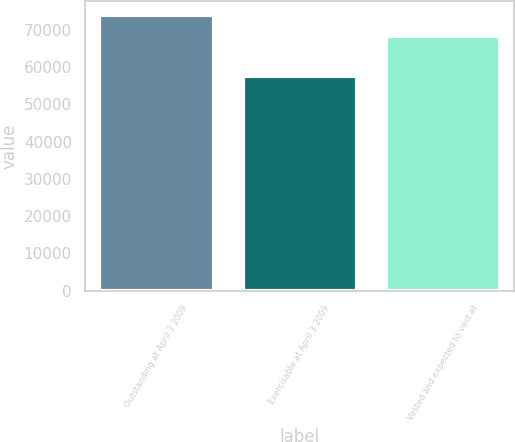Convert chart to OTSL. <chart><loc_0><loc_0><loc_500><loc_500><bar_chart><fcel>Outstanding at April 3 2009<fcel>Exercisable at April 3 2009<fcel>Vested and expected to vest at<nl><fcel>74023<fcel>57611<fcel>68472<nl></chart> 